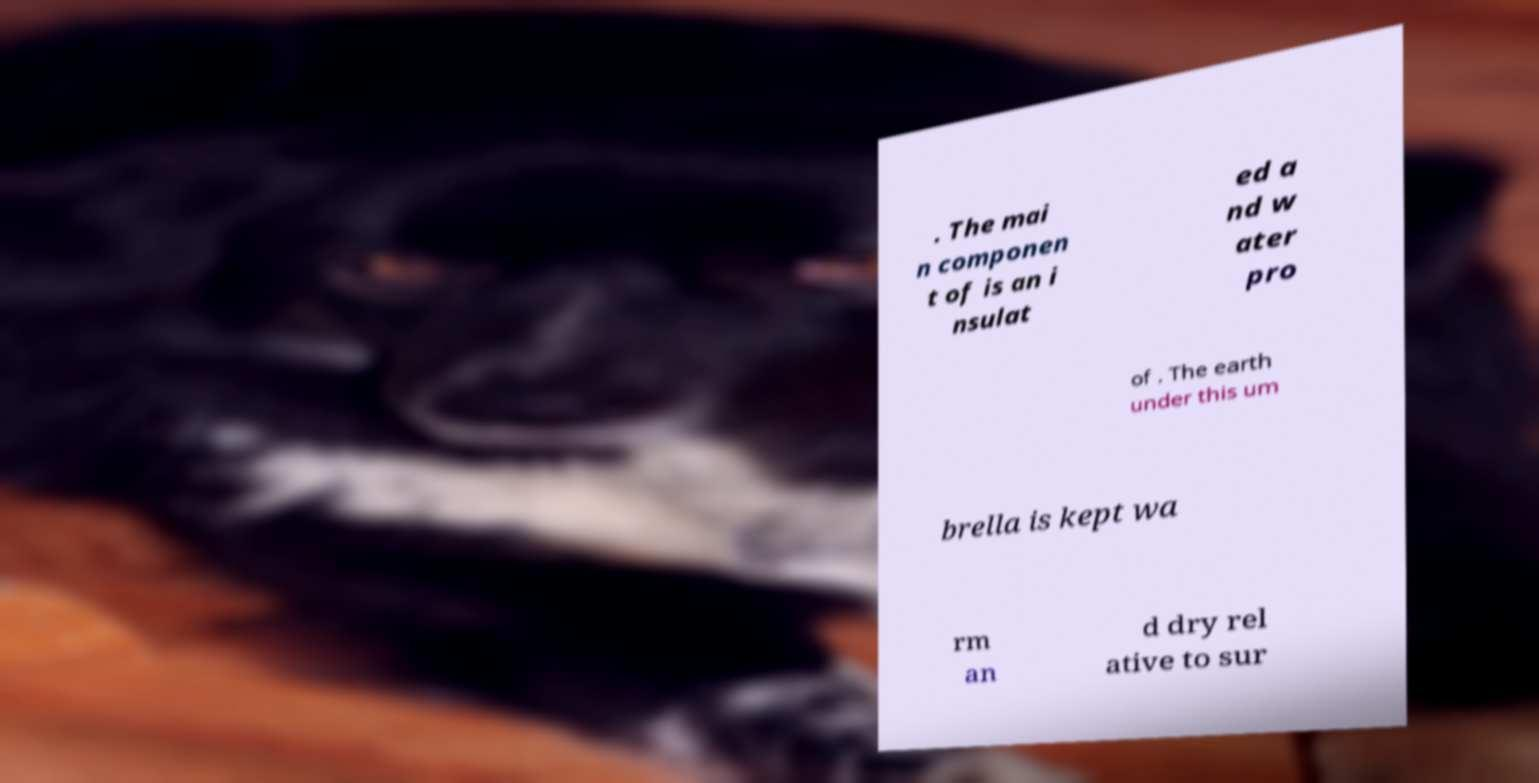Please identify and transcribe the text found in this image. . The mai n componen t of is an i nsulat ed a nd w ater pro of . The earth under this um brella is kept wa rm an d dry rel ative to sur 